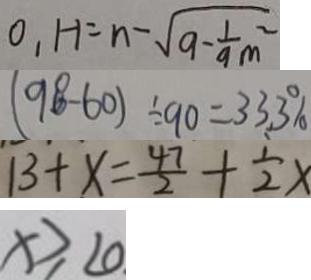<formula> <loc_0><loc_0><loc_500><loc_500>0 , H = n - \sqrt { 9 - \frac { 1 } { 9 } } m ^ { 2 } 
 ( 9 8 - 6 0 ) \div 9 0 = 3 3 . 3 \% 
 1 3 + x = \frac { 4 7 } { 2 } + \frac { 1 } { 2 } x 
 x \geq 2 0</formula> 